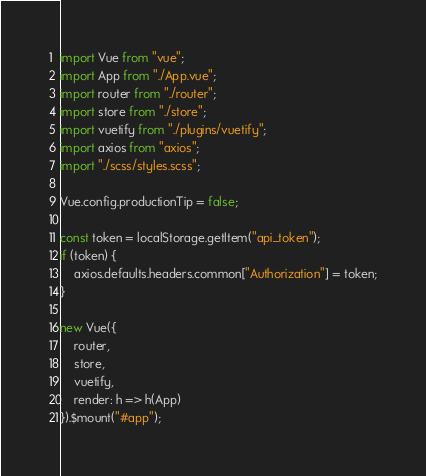<code> <loc_0><loc_0><loc_500><loc_500><_JavaScript_>import Vue from "vue";
import App from "./App.vue";
import router from "./router";
import store from "./store";
import vuetify from "./plugins/vuetify";
import axios from "axios";
import "./scss/styles.scss";

Vue.config.productionTip = false;

const token = localStorage.getItem("api_token");
if (token) {
    axios.defaults.headers.common["Authorization"] = token;
}

new Vue({
    router,
    store,
    vuetify,
    render: h => h(App)
}).$mount("#app");
</code> 